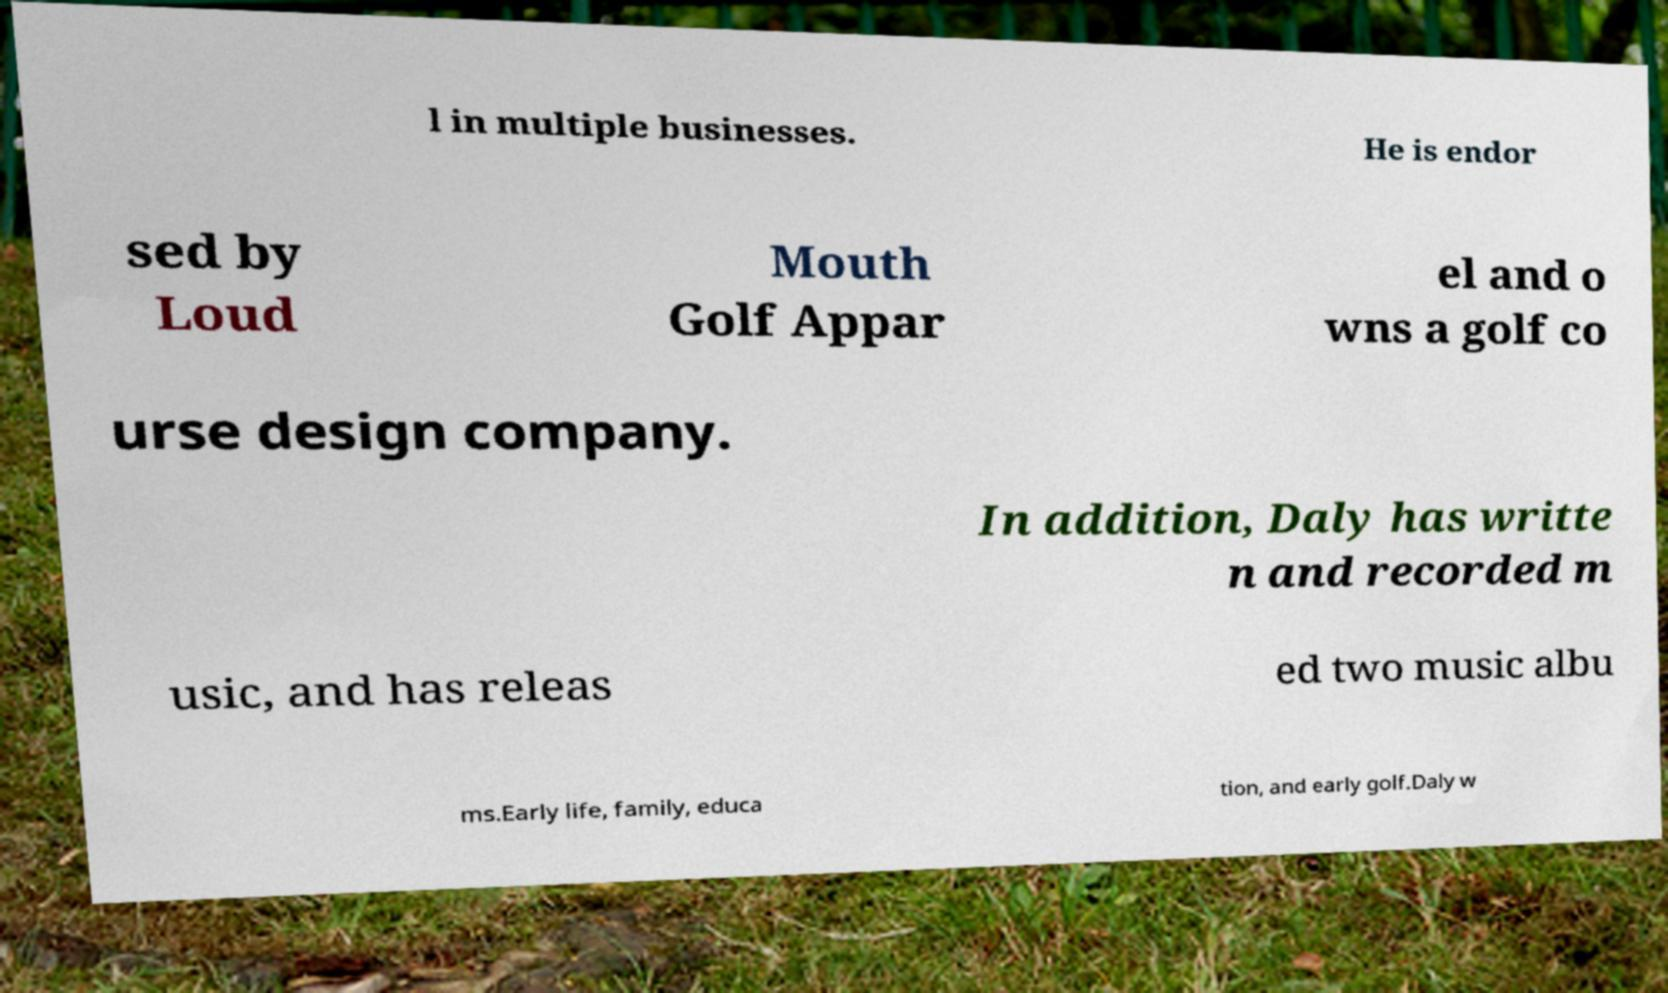Please identify and transcribe the text found in this image. l in multiple businesses. He is endor sed by Loud Mouth Golf Appar el and o wns a golf co urse design company. In addition, Daly has writte n and recorded m usic, and has releas ed two music albu ms.Early life, family, educa tion, and early golf.Daly w 